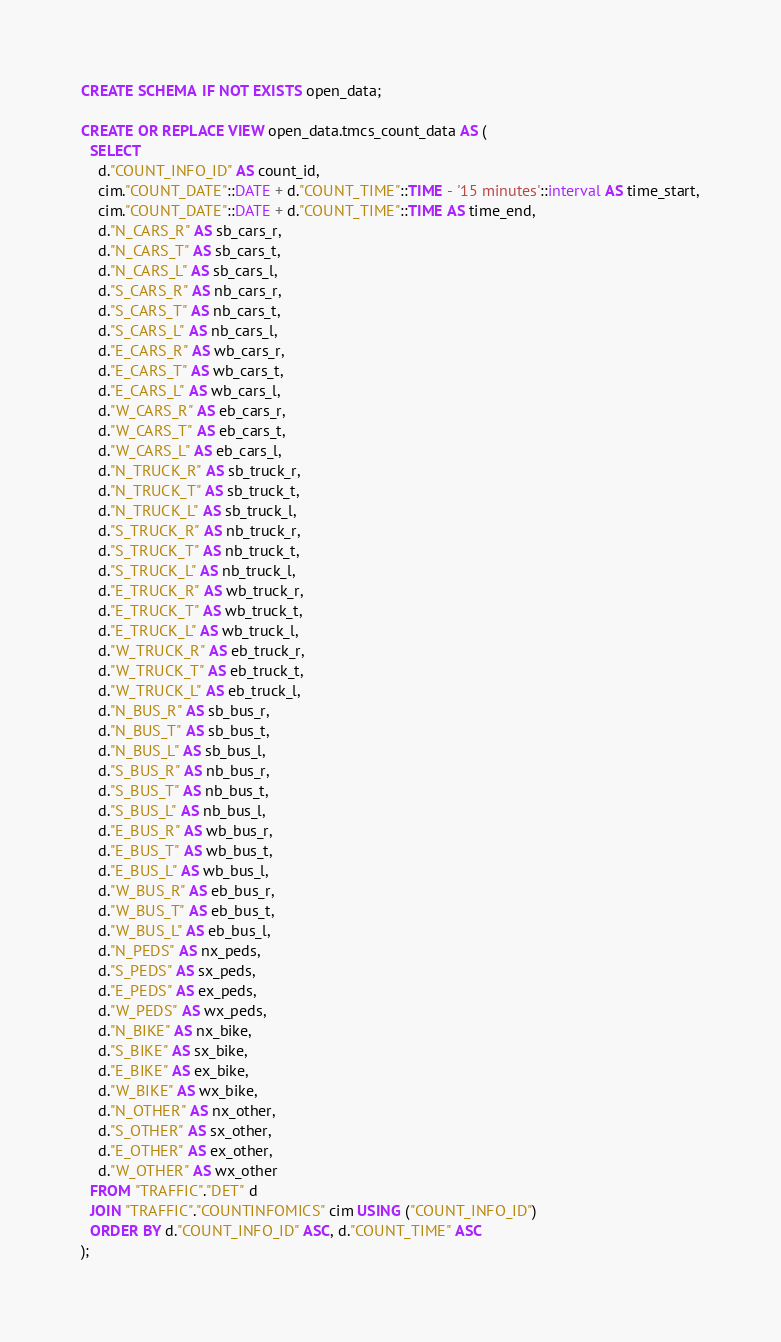Convert code to text. <code><loc_0><loc_0><loc_500><loc_500><_SQL_>CREATE SCHEMA IF NOT EXISTS open_data;

CREATE OR REPLACE VIEW open_data.tmcs_count_data AS (
  SELECT
    d."COUNT_INFO_ID" AS count_id,
    cim."COUNT_DATE"::DATE + d."COUNT_TIME"::TIME - '15 minutes'::interval AS time_start,
    cim."COUNT_DATE"::DATE + d."COUNT_TIME"::TIME AS time_end,
    d."N_CARS_R" AS sb_cars_r,
    d."N_CARS_T" AS sb_cars_t,
    d."N_CARS_L" AS sb_cars_l,
    d."S_CARS_R" AS nb_cars_r,
    d."S_CARS_T" AS nb_cars_t,
    d."S_CARS_L" AS nb_cars_l,
    d."E_CARS_R" AS wb_cars_r,
    d."E_CARS_T" AS wb_cars_t,
    d."E_CARS_L" AS wb_cars_l,
    d."W_CARS_R" AS eb_cars_r,
    d."W_CARS_T" AS eb_cars_t,
    d."W_CARS_L" AS eb_cars_l,
    d."N_TRUCK_R" AS sb_truck_r,
    d."N_TRUCK_T" AS sb_truck_t,
    d."N_TRUCK_L" AS sb_truck_l,
    d."S_TRUCK_R" AS nb_truck_r,
    d."S_TRUCK_T" AS nb_truck_t,
    d."S_TRUCK_L" AS nb_truck_l,
    d."E_TRUCK_R" AS wb_truck_r,
    d."E_TRUCK_T" AS wb_truck_t,
    d."E_TRUCK_L" AS wb_truck_l,
    d."W_TRUCK_R" AS eb_truck_r,
    d."W_TRUCK_T" AS eb_truck_t,
    d."W_TRUCK_L" AS eb_truck_l,
    d."N_BUS_R" AS sb_bus_r,
    d."N_BUS_T" AS sb_bus_t,
    d."N_BUS_L" AS sb_bus_l,
    d."S_BUS_R" AS nb_bus_r,
    d."S_BUS_T" AS nb_bus_t,
    d."S_BUS_L" AS nb_bus_l,
    d."E_BUS_R" AS wb_bus_r,
    d."E_BUS_T" AS wb_bus_t,
    d."E_BUS_L" AS wb_bus_l,
    d."W_BUS_R" AS eb_bus_r,
    d."W_BUS_T" AS eb_bus_t,
    d."W_BUS_L" AS eb_bus_l,
    d."N_PEDS" AS nx_peds,
    d."S_PEDS" AS sx_peds,
    d."E_PEDS" AS ex_peds,
    d."W_PEDS" AS wx_peds,
    d."N_BIKE" AS nx_bike,
    d."S_BIKE" AS sx_bike,
    d."E_BIKE" AS ex_bike,
    d."W_BIKE" AS wx_bike,
    d."N_OTHER" AS nx_other,
    d."S_OTHER" AS sx_other,
    d."E_OTHER" AS ex_other,
    d."W_OTHER" AS wx_other
  FROM "TRAFFIC"."DET" d
  JOIN "TRAFFIC"."COUNTINFOMICS" cim USING ("COUNT_INFO_ID")
  ORDER BY d."COUNT_INFO_ID" ASC, d."COUNT_TIME" ASC
);
</code> 